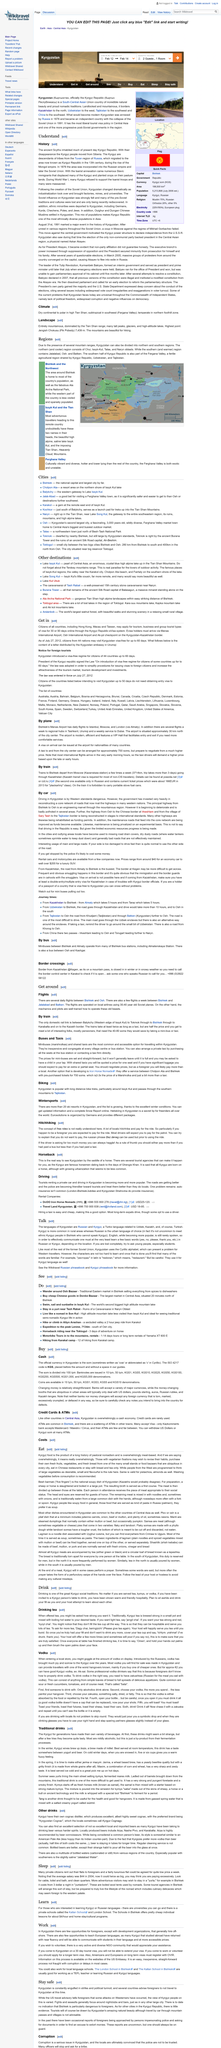List a handful of essential elements in this visual. Auto insurance is not common when driving in Kyrgyzstan. In Kyrgyzstan, the official language is Russian, and the Kyrgyz people also speak and write in Kyrgyz, using the Cyrillic alphabet. The reason they do not fill the tea cup all the way is to be hospitable and serve the customer multiple cups of tea. Mini buses and shared taxis are two types of transportation services, but they differ in several ways. Mini buses have set prices and don't leave until they are full, while shared taxis require payment for one seat, but may require an additional fee for extra luggage. It is not possible to extend a 30-day tourist visa that was obtained to enter Kyrgyzstan. 